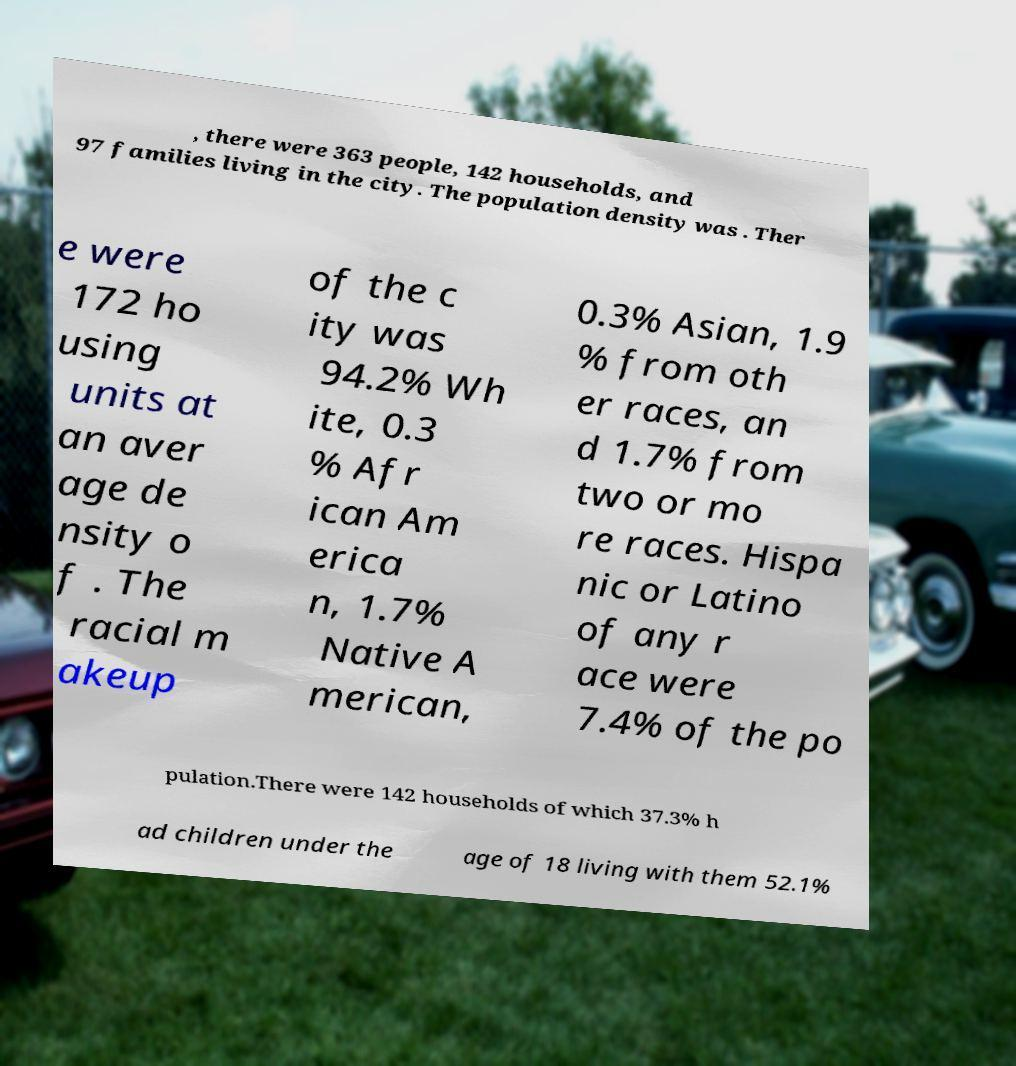Can you read and provide the text displayed in the image?This photo seems to have some interesting text. Can you extract and type it out for me? , there were 363 people, 142 households, and 97 families living in the city. The population density was . Ther e were 172 ho using units at an aver age de nsity o f . The racial m akeup of the c ity was 94.2% Wh ite, 0.3 % Afr ican Am erica n, 1.7% Native A merican, 0.3% Asian, 1.9 % from oth er races, an d 1.7% from two or mo re races. Hispa nic or Latino of any r ace were 7.4% of the po pulation.There were 142 households of which 37.3% h ad children under the age of 18 living with them 52.1% 